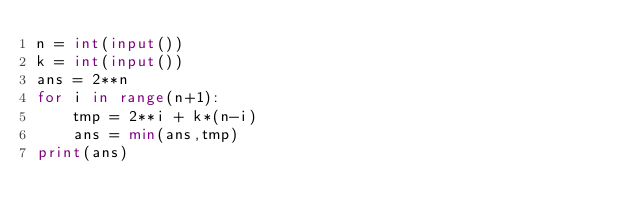<code> <loc_0><loc_0><loc_500><loc_500><_Python_>n = int(input())
k = int(input())
ans = 2**n
for i in range(n+1):
    tmp = 2**i + k*(n-i)
    ans = min(ans,tmp)
print(ans)
</code> 